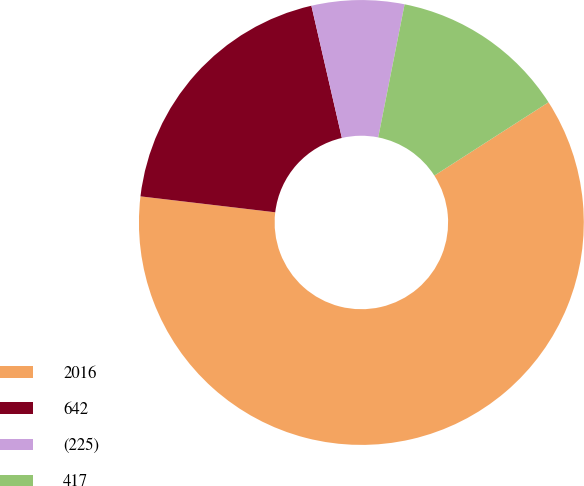<chart> <loc_0><loc_0><loc_500><loc_500><pie_chart><fcel>2016<fcel>642<fcel>(225)<fcel>417<nl><fcel>60.96%<fcel>19.52%<fcel>6.72%<fcel>12.8%<nl></chart> 